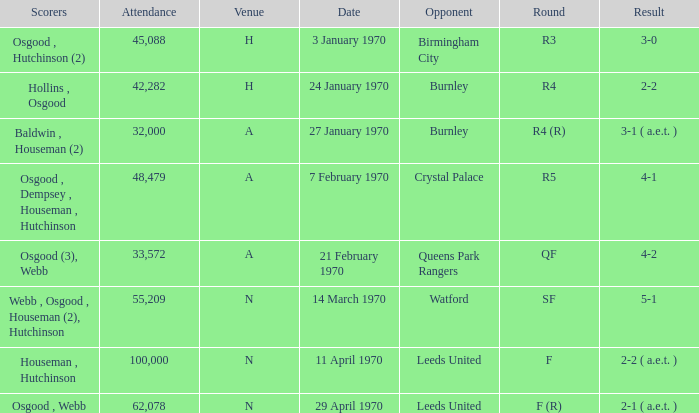What round was the game against Watford? SF. Could you help me parse every detail presented in this table? {'header': ['Scorers', 'Attendance', 'Venue', 'Date', 'Opponent', 'Round', 'Result'], 'rows': [['Osgood , Hutchinson (2)', '45,088', 'H', '3 January 1970', 'Birmingham City', 'R3', '3-0'], ['Hollins , Osgood', '42,282', 'H', '24 January 1970', 'Burnley', 'R4', '2-2'], ['Baldwin , Houseman (2)', '32,000', 'A', '27 January 1970', 'Burnley', 'R4 (R)', '3-1 ( a.e.t. )'], ['Osgood , Dempsey , Houseman , Hutchinson', '48,479', 'A', '7 February 1970', 'Crystal Palace', 'R5', '4-1'], ['Osgood (3), Webb', '33,572', 'A', '21 February 1970', 'Queens Park Rangers', 'QF', '4-2'], ['Webb , Osgood , Houseman (2), Hutchinson', '55,209', 'N', '14 March 1970', 'Watford', 'SF', '5-1'], ['Houseman , Hutchinson', '100,000', 'N', '11 April 1970', 'Leeds United', 'F', '2-2 ( a.e.t. )'], ['Osgood , Webb', '62,078', 'N', '29 April 1970', 'Leeds United', 'F (R)', '2-1 ( a.e.t. )']]} 